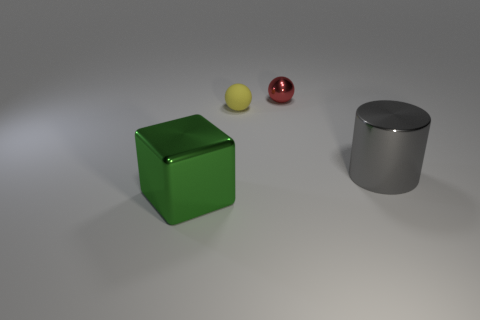How many objects are in front of the small rubber thing and on the left side of the red ball?
Provide a succinct answer. 1. How many things are shiny spheres or yellow rubber balls left of the red object?
Your answer should be very brief. 2. There is a small thing in front of the red object; what color is it?
Offer a terse response. Yellow. What number of objects are either metallic objects that are to the left of the tiny metallic object or gray cylinders?
Keep it short and to the point. 2. There is a metallic cube that is the same size as the cylinder; what color is it?
Your response must be concise. Green. Are there more tiny matte spheres on the left side of the large green metallic block than small objects?
Offer a very short reply. No. What is the material of the thing that is both in front of the small shiny object and behind the large cylinder?
Make the answer very short. Rubber. How many other objects are there of the same size as the yellow rubber object?
Give a very brief answer. 1. There is a metal thing in front of the big thing that is right of the tiny red sphere; are there any yellow rubber objects that are behind it?
Your answer should be compact. Yes. Does the large thing that is to the right of the block have the same material as the small red thing?
Provide a short and direct response. Yes. 